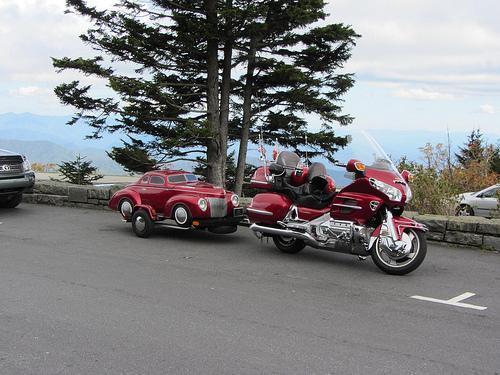How many people can ride on this motorcycle?
Give a very brief answer. 2. 